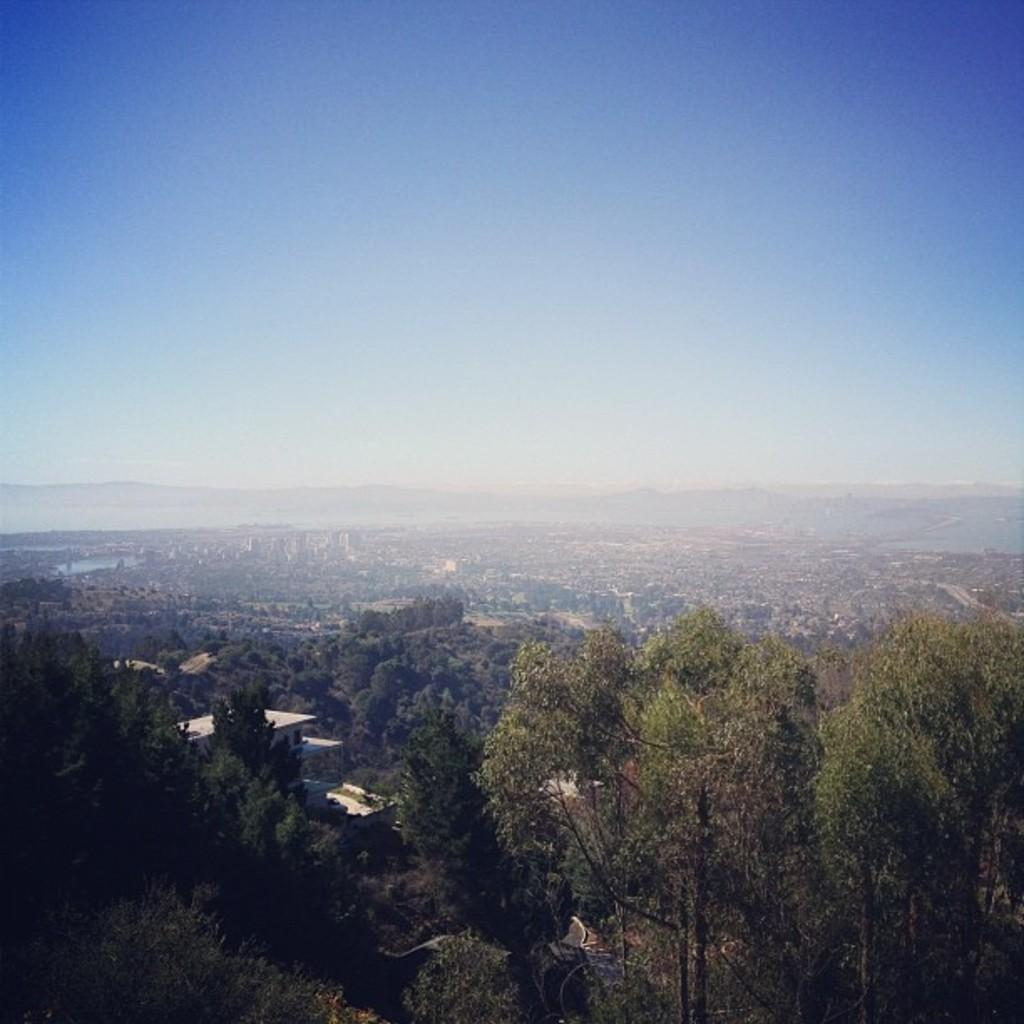What type of landscape is depicted in the image? The image shows open land with a building, trees, plants, and grass. Can you describe the background of the image? In the background, there is a mountain and a water lake. What is visible at the top of the image? The sky is visible at the top of the image. What type of surprise can be seen in the image? There is no surprise present in the image; it depicts a landscape with various natural elements and a building. Can you tell me how many knees are visible in the image? There are no knees visible in the image, as it features a landscape with natural elements and a building. 